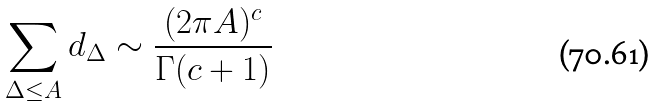Convert formula to latex. <formula><loc_0><loc_0><loc_500><loc_500>\sum _ { \Delta \leq A } d _ { \Delta } \sim \frac { ( 2 \pi A ) ^ { c } } { \Gamma ( c + 1 ) }</formula> 